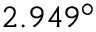Convert formula to latex. <formula><loc_0><loc_0><loc_500><loc_500>2 . 9 4 9 ^ { \circ }</formula> 